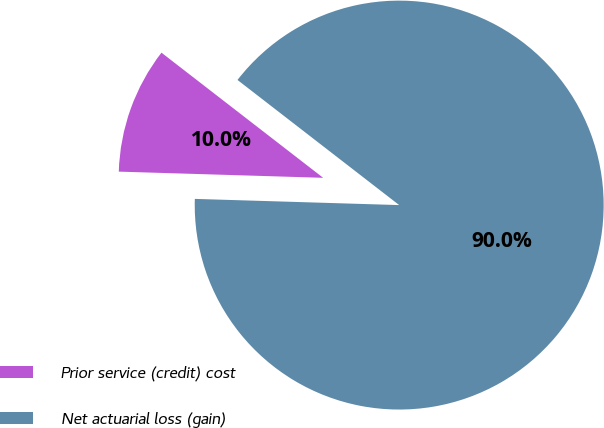<chart> <loc_0><loc_0><loc_500><loc_500><pie_chart><fcel>Prior service (credit) cost<fcel>Net actuarial loss (gain)<nl><fcel>10.0%<fcel>90.0%<nl></chart> 